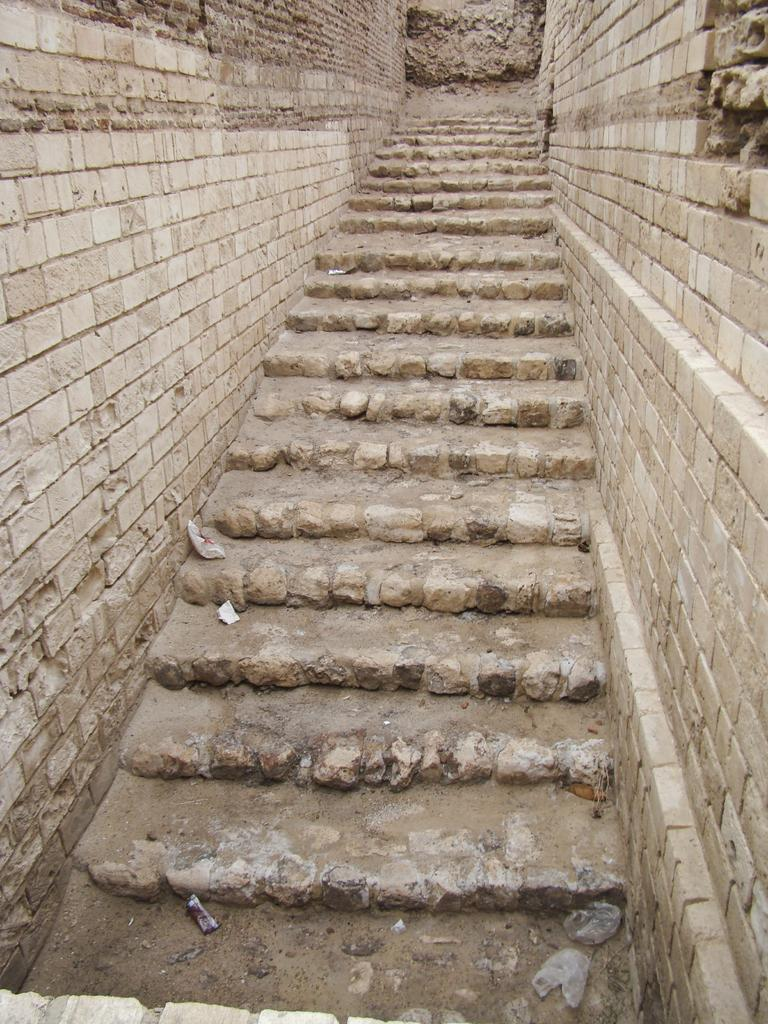What is the main feature in the middle of the image? There are stairs at the center of the image. What can be seen on the right side of the image? There is a wall on the right side of the image. What is present on the left side of the image? There is a wall on the left side of the image. Can you see a boat floating near the stairs in the image? No, there is no boat present in the image. Is there a snake slithering on the stairs in the image? No, there is no snake present in the image. 